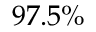<formula> <loc_0><loc_0><loc_500><loc_500>9 7 . 5 \%</formula> 